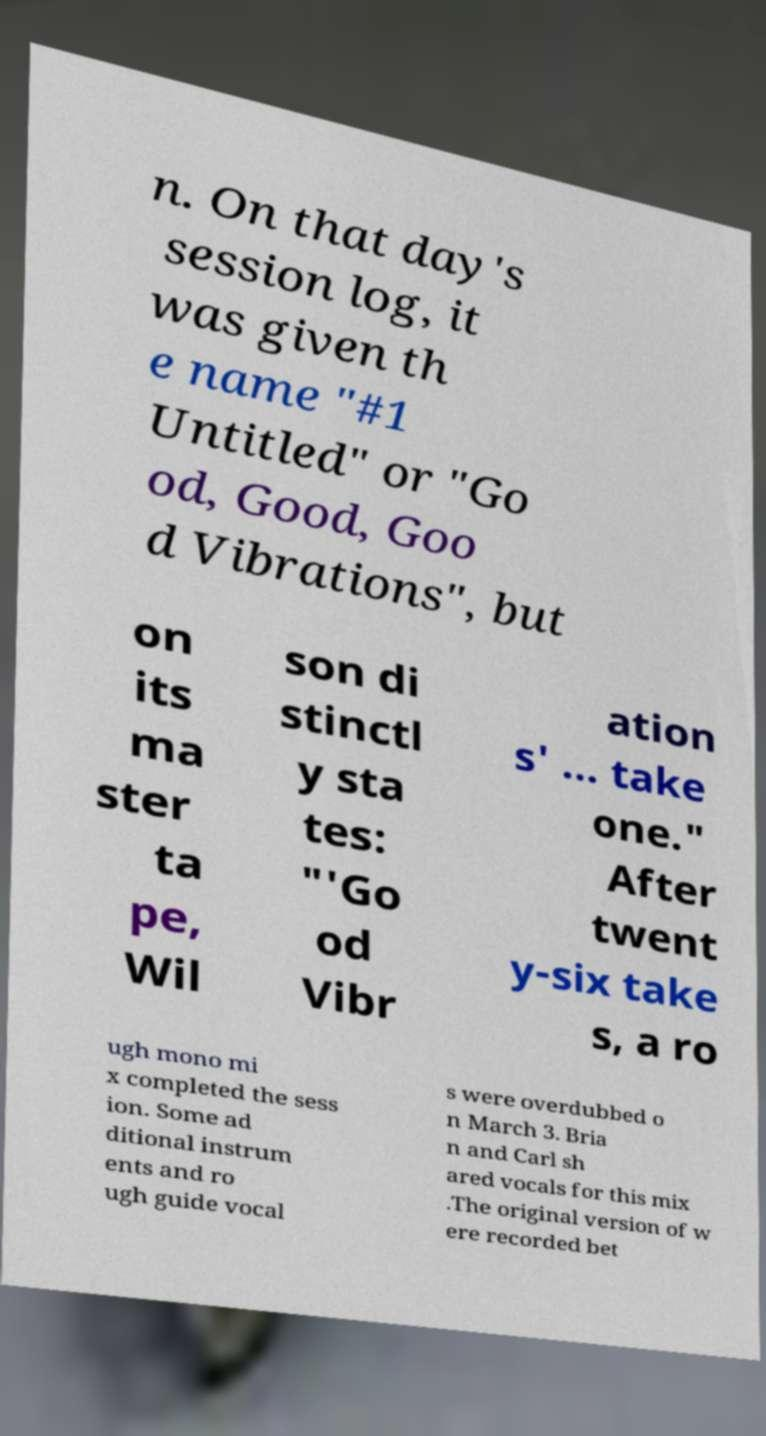There's text embedded in this image that I need extracted. Can you transcribe it verbatim? n. On that day's session log, it was given th e name "#1 Untitled" or "Go od, Good, Goo d Vibrations", but on its ma ster ta pe, Wil son di stinctl y sta tes: "'Go od Vibr ation s' ... take one." After twent y-six take s, a ro ugh mono mi x completed the sess ion. Some ad ditional instrum ents and ro ugh guide vocal s were overdubbed o n March 3. Bria n and Carl sh ared vocals for this mix .The original version of w ere recorded bet 